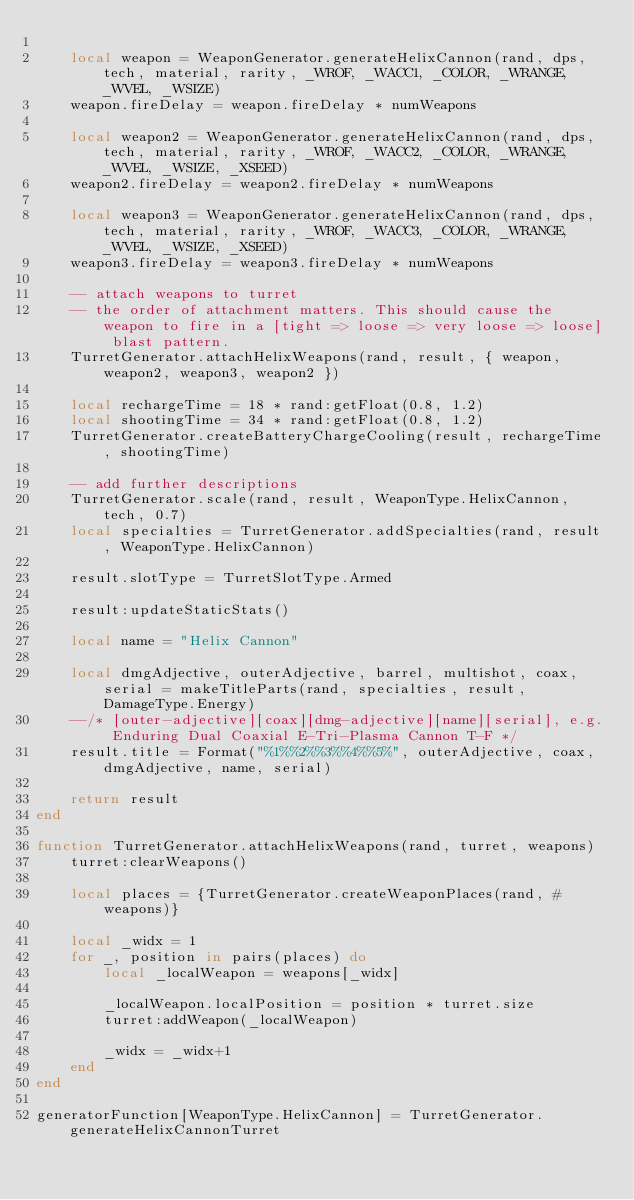Convert code to text. <code><loc_0><loc_0><loc_500><loc_500><_Lua_>
    local weapon = WeaponGenerator.generateHelixCannon(rand, dps, tech, material, rarity, _WROF, _WACC1, _COLOR, _WRANGE, _WVEL, _WSIZE)
    weapon.fireDelay = weapon.fireDelay * numWeapons

    local weapon2 = WeaponGenerator.generateHelixCannon(rand, dps, tech, material, rarity, _WROF, _WACC2, _COLOR, _WRANGE, _WVEL, _WSIZE, _XSEED)
    weapon2.fireDelay = weapon2.fireDelay * numWeapons

    local weapon3 = WeaponGenerator.generateHelixCannon(rand, dps, tech, material, rarity, _WROF, _WACC3, _COLOR, _WRANGE, _WVEL, _WSIZE, _XSEED)
    weapon3.fireDelay = weapon3.fireDelay * numWeapons

    -- attach weapons to turret
    -- the order of attachment matters. This should cause the weapon to fire in a [tight => loose => very loose => loose] blast pattern.
    TurretGenerator.attachHelixWeapons(rand, result, { weapon, weapon2, weapon3, weapon2 })

    local rechargeTime = 18 * rand:getFloat(0.8, 1.2)
    local shootingTime = 34 * rand:getFloat(0.8, 1.2)
    TurretGenerator.createBatteryChargeCooling(result, rechargeTime, shootingTime)

    -- add further descriptions
    TurretGenerator.scale(rand, result, WeaponType.HelixCannon, tech, 0.7)
    local specialties = TurretGenerator.addSpecialties(rand, result, WeaponType.HelixCannon)

    result.slotType = TurretSlotType.Armed

    result:updateStaticStats()

    local name = "Helix Cannon"

    local dmgAdjective, outerAdjective, barrel, multishot, coax, serial = makeTitleParts(rand, specialties, result, DamageType.Energy)
    --/* [outer-adjective][coax][dmg-adjective][name][serial], e.g. Enduring Dual Coaxial E-Tri-Plasma Cannon T-F */
    result.title = Format("%1%%2%%3%%4%%5%", outerAdjective, coax, dmgAdjective, name, serial)

    return result
end

function TurretGenerator.attachHelixWeapons(rand, turret, weapons)
    turret:clearWeapons()

    local places = {TurretGenerator.createWeaponPlaces(rand, #weapons)}

    local _widx = 1
    for _, position in pairs(places) do
        local _localWeapon = weapons[_widx]

        _localWeapon.localPosition = position * turret.size
        turret:addWeapon(_localWeapon)

        _widx = _widx+1
    end
end

generatorFunction[WeaponType.HelixCannon] = TurretGenerator.generateHelixCannonTurret</code> 